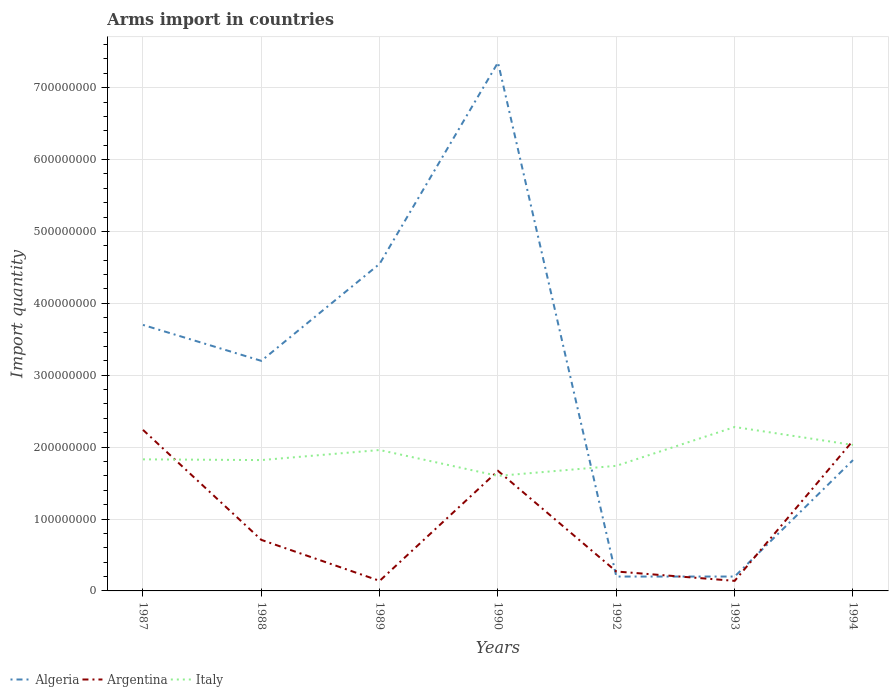How many different coloured lines are there?
Your response must be concise. 3. Does the line corresponding to Argentina intersect with the line corresponding to Italy?
Offer a very short reply. Yes. Across all years, what is the maximum total arms import in Argentina?
Offer a terse response. 1.40e+07. In which year was the total arms import in Algeria maximum?
Give a very brief answer. 1992. What is the total total arms import in Algeria in the graph?
Your answer should be compact. 3.50e+08. What is the difference between the highest and the second highest total arms import in Algeria?
Ensure brevity in your answer.  7.15e+08. What is the difference between the highest and the lowest total arms import in Italy?
Make the answer very short. 3. Is the total arms import in Algeria strictly greater than the total arms import in Italy over the years?
Offer a very short reply. No. How many lines are there?
Your response must be concise. 3. How many years are there in the graph?
Your answer should be very brief. 7. What is the difference between two consecutive major ticks on the Y-axis?
Ensure brevity in your answer.  1.00e+08. Where does the legend appear in the graph?
Make the answer very short. Bottom left. How many legend labels are there?
Offer a terse response. 3. How are the legend labels stacked?
Ensure brevity in your answer.  Horizontal. What is the title of the graph?
Give a very brief answer. Arms import in countries. Does "Panama" appear as one of the legend labels in the graph?
Your answer should be very brief. No. What is the label or title of the X-axis?
Offer a terse response. Years. What is the label or title of the Y-axis?
Your response must be concise. Import quantity. What is the Import quantity of Algeria in 1987?
Provide a succinct answer. 3.70e+08. What is the Import quantity of Argentina in 1987?
Provide a short and direct response. 2.24e+08. What is the Import quantity of Italy in 1987?
Your answer should be compact. 1.83e+08. What is the Import quantity in Algeria in 1988?
Make the answer very short. 3.20e+08. What is the Import quantity in Argentina in 1988?
Your response must be concise. 7.10e+07. What is the Import quantity of Italy in 1988?
Provide a succinct answer. 1.82e+08. What is the Import quantity of Algeria in 1989?
Provide a short and direct response. 4.55e+08. What is the Import quantity of Argentina in 1989?
Keep it short and to the point. 1.40e+07. What is the Import quantity in Italy in 1989?
Provide a succinct answer. 1.96e+08. What is the Import quantity in Algeria in 1990?
Offer a very short reply. 7.35e+08. What is the Import quantity of Argentina in 1990?
Offer a terse response. 1.67e+08. What is the Import quantity in Italy in 1990?
Your answer should be very brief. 1.60e+08. What is the Import quantity of Argentina in 1992?
Offer a very short reply. 2.70e+07. What is the Import quantity in Italy in 1992?
Offer a terse response. 1.74e+08. What is the Import quantity in Argentina in 1993?
Your answer should be very brief. 1.40e+07. What is the Import quantity in Italy in 1993?
Make the answer very short. 2.28e+08. What is the Import quantity in Algeria in 1994?
Offer a terse response. 1.82e+08. What is the Import quantity of Argentina in 1994?
Provide a short and direct response. 2.09e+08. What is the Import quantity of Italy in 1994?
Your answer should be compact. 2.03e+08. Across all years, what is the maximum Import quantity in Algeria?
Ensure brevity in your answer.  7.35e+08. Across all years, what is the maximum Import quantity of Argentina?
Offer a terse response. 2.24e+08. Across all years, what is the maximum Import quantity of Italy?
Your answer should be very brief. 2.28e+08. Across all years, what is the minimum Import quantity of Algeria?
Offer a very short reply. 2.00e+07. Across all years, what is the minimum Import quantity of Argentina?
Provide a succinct answer. 1.40e+07. Across all years, what is the minimum Import quantity in Italy?
Provide a short and direct response. 1.60e+08. What is the total Import quantity in Algeria in the graph?
Keep it short and to the point. 2.10e+09. What is the total Import quantity of Argentina in the graph?
Your answer should be very brief. 7.26e+08. What is the total Import quantity of Italy in the graph?
Ensure brevity in your answer.  1.33e+09. What is the difference between the Import quantity of Argentina in 1987 and that in 1988?
Provide a short and direct response. 1.53e+08. What is the difference between the Import quantity in Italy in 1987 and that in 1988?
Offer a terse response. 1.00e+06. What is the difference between the Import quantity of Algeria in 1987 and that in 1989?
Give a very brief answer. -8.50e+07. What is the difference between the Import quantity in Argentina in 1987 and that in 1989?
Ensure brevity in your answer.  2.10e+08. What is the difference between the Import quantity of Italy in 1987 and that in 1989?
Provide a short and direct response. -1.30e+07. What is the difference between the Import quantity of Algeria in 1987 and that in 1990?
Make the answer very short. -3.65e+08. What is the difference between the Import quantity of Argentina in 1987 and that in 1990?
Make the answer very short. 5.70e+07. What is the difference between the Import quantity of Italy in 1987 and that in 1990?
Give a very brief answer. 2.30e+07. What is the difference between the Import quantity of Algeria in 1987 and that in 1992?
Give a very brief answer. 3.50e+08. What is the difference between the Import quantity of Argentina in 1987 and that in 1992?
Provide a short and direct response. 1.97e+08. What is the difference between the Import quantity in Italy in 1987 and that in 1992?
Keep it short and to the point. 9.00e+06. What is the difference between the Import quantity of Algeria in 1987 and that in 1993?
Your response must be concise. 3.50e+08. What is the difference between the Import quantity in Argentina in 1987 and that in 1993?
Ensure brevity in your answer.  2.10e+08. What is the difference between the Import quantity in Italy in 1987 and that in 1993?
Make the answer very short. -4.50e+07. What is the difference between the Import quantity of Algeria in 1987 and that in 1994?
Your answer should be very brief. 1.88e+08. What is the difference between the Import quantity in Argentina in 1987 and that in 1994?
Keep it short and to the point. 1.50e+07. What is the difference between the Import quantity in Italy in 1987 and that in 1994?
Ensure brevity in your answer.  -2.00e+07. What is the difference between the Import quantity in Algeria in 1988 and that in 1989?
Make the answer very short. -1.35e+08. What is the difference between the Import quantity of Argentina in 1988 and that in 1989?
Ensure brevity in your answer.  5.70e+07. What is the difference between the Import quantity in Italy in 1988 and that in 1989?
Offer a very short reply. -1.40e+07. What is the difference between the Import quantity of Algeria in 1988 and that in 1990?
Your response must be concise. -4.15e+08. What is the difference between the Import quantity of Argentina in 1988 and that in 1990?
Offer a very short reply. -9.60e+07. What is the difference between the Import quantity in Italy in 1988 and that in 1990?
Ensure brevity in your answer.  2.20e+07. What is the difference between the Import quantity of Algeria in 1988 and that in 1992?
Keep it short and to the point. 3.00e+08. What is the difference between the Import quantity in Argentina in 1988 and that in 1992?
Offer a very short reply. 4.40e+07. What is the difference between the Import quantity of Italy in 1988 and that in 1992?
Your answer should be compact. 8.00e+06. What is the difference between the Import quantity of Algeria in 1988 and that in 1993?
Provide a short and direct response. 3.00e+08. What is the difference between the Import quantity of Argentina in 1988 and that in 1993?
Your response must be concise. 5.70e+07. What is the difference between the Import quantity in Italy in 1988 and that in 1993?
Your response must be concise. -4.60e+07. What is the difference between the Import quantity of Algeria in 1988 and that in 1994?
Provide a short and direct response. 1.38e+08. What is the difference between the Import quantity of Argentina in 1988 and that in 1994?
Provide a succinct answer. -1.38e+08. What is the difference between the Import quantity in Italy in 1988 and that in 1994?
Provide a short and direct response. -2.10e+07. What is the difference between the Import quantity of Algeria in 1989 and that in 1990?
Provide a succinct answer. -2.80e+08. What is the difference between the Import quantity in Argentina in 1989 and that in 1990?
Make the answer very short. -1.53e+08. What is the difference between the Import quantity of Italy in 1989 and that in 1990?
Keep it short and to the point. 3.60e+07. What is the difference between the Import quantity of Algeria in 1989 and that in 1992?
Ensure brevity in your answer.  4.35e+08. What is the difference between the Import quantity of Argentina in 1989 and that in 1992?
Ensure brevity in your answer.  -1.30e+07. What is the difference between the Import quantity of Italy in 1989 and that in 1992?
Your response must be concise. 2.20e+07. What is the difference between the Import quantity of Algeria in 1989 and that in 1993?
Ensure brevity in your answer.  4.35e+08. What is the difference between the Import quantity of Italy in 1989 and that in 1993?
Your answer should be compact. -3.20e+07. What is the difference between the Import quantity of Algeria in 1989 and that in 1994?
Provide a succinct answer. 2.73e+08. What is the difference between the Import quantity in Argentina in 1989 and that in 1994?
Ensure brevity in your answer.  -1.95e+08. What is the difference between the Import quantity in Italy in 1989 and that in 1994?
Your answer should be compact. -7.00e+06. What is the difference between the Import quantity in Algeria in 1990 and that in 1992?
Make the answer very short. 7.15e+08. What is the difference between the Import quantity of Argentina in 1990 and that in 1992?
Offer a terse response. 1.40e+08. What is the difference between the Import quantity of Italy in 1990 and that in 1992?
Your answer should be very brief. -1.40e+07. What is the difference between the Import quantity in Algeria in 1990 and that in 1993?
Make the answer very short. 7.15e+08. What is the difference between the Import quantity in Argentina in 1990 and that in 1993?
Your answer should be very brief. 1.53e+08. What is the difference between the Import quantity of Italy in 1990 and that in 1993?
Make the answer very short. -6.80e+07. What is the difference between the Import quantity in Algeria in 1990 and that in 1994?
Offer a terse response. 5.53e+08. What is the difference between the Import quantity of Argentina in 1990 and that in 1994?
Give a very brief answer. -4.20e+07. What is the difference between the Import quantity of Italy in 1990 and that in 1994?
Give a very brief answer. -4.30e+07. What is the difference between the Import quantity in Algeria in 1992 and that in 1993?
Ensure brevity in your answer.  0. What is the difference between the Import quantity in Argentina in 1992 and that in 1993?
Your response must be concise. 1.30e+07. What is the difference between the Import quantity in Italy in 1992 and that in 1993?
Offer a terse response. -5.40e+07. What is the difference between the Import quantity in Algeria in 1992 and that in 1994?
Offer a very short reply. -1.62e+08. What is the difference between the Import quantity in Argentina in 1992 and that in 1994?
Your answer should be very brief. -1.82e+08. What is the difference between the Import quantity in Italy in 1992 and that in 1994?
Your response must be concise. -2.90e+07. What is the difference between the Import quantity of Algeria in 1993 and that in 1994?
Provide a short and direct response. -1.62e+08. What is the difference between the Import quantity in Argentina in 1993 and that in 1994?
Offer a terse response. -1.95e+08. What is the difference between the Import quantity in Italy in 1993 and that in 1994?
Offer a very short reply. 2.50e+07. What is the difference between the Import quantity in Algeria in 1987 and the Import quantity in Argentina in 1988?
Offer a very short reply. 2.99e+08. What is the difference between the Import quantity in Algeria in 1987 and the Import quantity in Italy in 1988?
Your response must be concise. 1.88e+08. What is the difference between the Import quantity in Argentina in 1987 and the Import quantity in Italy in 1988?
Your answer should be compact. 4.20e+07. What is the difference between the Import quantity of Algeria in 1987 and the Import quantity of Argentina in 1989?
Offer a terse response. 3.56e+08. What is the difference between the Import quantity in Algeria in 1987 and the Import quantity in Italy in 1989?
Your answer should be very brief. 1.74e+08. What is the difference between the Import quantity in Argentina in 1987 and the Import quantity in Italy in 1989?
Ensure brevity in your answer.  2.80e+07. What is the difference between the Import quantity in Algeria in 1987 and the Import quantity in Argentina in 1990?
Offer a very short reply. 2.03e+08. What is the difference between the Import quantity in Algeria in 1987 and the Import quantity in Italy in 1990?
Keep it short and to the point. 2.10e+08. What is the difference between the Import quantity of Argentina in 1987 and the Import quantity of Italy in 1990?
Make the answer very short. 6.40e+07. What is the difference between the Import quantity in Algeria in 1987 and the Import quantity in Argentina in 1992?
Keep it short and to the point. 3.43e+08. What is the difference between the Import quantity of Algeria in 1987 and the Import quantity of Italy in 1992?
Offer a terse response. 1.96e+08. What is the difference between the Import quantity in Argentina in 1987 and the Import quantity in Italy in 1992?
Ensure brevity in your answer.  5.00e+07. What is the difference between the Import quantity of Algeria in 1987 and the Import quantity of Argentina in 1993?
Offer a terse response. 3.56e+08. What is the difference between the Import quantity in Algeria in 1987 and the Import quantity in Italy in 1993?
Make the answer very short. 1.42e+08. What is the difference between the Import quantity in Argentina in 1987 and the Import quantity in Italy in 1993?
Provide a short and direct response. -4.00e+06. What is the difference between the Import quantity of Algeria in 1987 and the Import quantity of Argentina in 1994?
Give a very brief answer. 1.61e+08. What is the difference between the Import quantity in Algeria in 1987 and the Import quantity in Italy in 1994?
Offer a very short reply. 1.67e+08. What is the difference between the Import quantity of Argentina in 1987 and the Import quantity of Italy in 1994?
Keep it short and to the point. 2.10e+07. What is the difference between the Import quantity of Algeria in 1988 and the Import quantity of Argentina in 1989?
Provide a short and direct response. 3.06e+08. What is the difference between the Import quantity of Algeria in 1988 and the Import quantity of Italy in 1989?
Keep it short and to the point. 1.24e+08. What is the difference between the Import quantity in Argentina in 1988 and the Import quantity in Italy in 1989?
Offer a very short reply. -1.25e+08. What is the difference between the Import quantity in Algeria in 1988 and the Import quantity in Argentina in 1990?
Your answer should be compact. 1.53e+08. What is the difference between the Import quantity of Algeria in 1988 and the Import quantity of Italy in 1990?
Your response must be concise. 1.60e+08. What is the difference between the Import quantity of Argentina in 1988 and the Import quantity of Italy in 1990?
Ensure brevity in your answer.  -8.90e+07. What is the difference between the Import quantity in Algeria in 1988 and the Import quantity in Argentina in 1992?
Your answer should be compact. 2.93e+08. What is the difference between the Import quantity in Algeria in 1988 and the Import quantity in Italy in 1992?
Keep it short and to the point. 1.46e+08. What is the difference between the Import quantity of Argentina in 1988 and the Import quantity of Italy in 1992?
Your response must be concise. -1.03e+08. What is the difference between the Import quantity of Algeria in 1988 and the Import quantity of Argentina in 1993?
Keep it short and to the point. 3.06e+08. What is the difference between the Import quantity in Algeria in 1988 and the Import quantity in Italy in 1993?
Your response must be concise. 9.20e+07. What is the difference between the Import quantity in Argentina in 1988 and the Import quantity in Italy in 1993?
Your answer should be compact. -1.57e+08. What is the difference between the Import quantity in Algeria in 1988 and the Import quantity in Argentina in 1994?
Keep it short and to the point. 1.11e+08. What is the difference between the Import quantity of Algeria in 1988 and the Import quantity of Italy in 1994?
Your answer should be compact. 1.17e+08. What is the difference between the Import quantity in Argentina in 1988 and the Import quantity in Italy in 1994?
Give a very brief answer. -1.32e+08. What is the difference between the Import quantity of Algeria in 1989 and the Import quantity of Argentina in 1990?
Provide a succinct answer. 2.88e+08. What is the difference between the Import quantity in Algeria in 1989 and the Import quantity in Italy in 1990?
Make the answer very short. 2.95e+08. What is the difference between the Import quantity of Argentina in 1989 and the Import quantity of Italy in 1990?
Provide a short and direct response. -1.46e+08. What is the difference between the Import quantity in Algeria in 1989 and the Import quantity in Argentina in 1992?
Ensure brevity in your answer.  4.28e+08. What is the difference between the Import quantity in Algeria in 1989 and the Import quantity in Italy in 1992?
Offer a very short reply. 2.81e+08. What is the difference between the Import quantity in Argentina in 1989 and the Import quantity in Italy in 1992?
Offer a very short reply. -1.60e+08. What is the difference between the Import quantity in Algeria in 1989 and the Import quantity in Argentina in 1993?
Provide a succinct answer. 4.41e+08. What is the difference between the Import quantity in Algeria in 1989 and the Import quantity in Italy in 1993?
Give a very brief answer. 2.27e+08. What is the difference between the Import quantity in Argentina in 1989 and the Import quantity in Italy in 1993?
Give a very brief answer. -2.14e+08. What is the difference between the Import quantity in Algeria in 1989 and the Import quantity in Argentina in 1994?
Provide a short and direct response. 2.46e+08. What is the difference between the Import quantity of Algeria in 1989 and the Import quantity of Italy in 1994?
Make the answer very short. 2.52e+08. What is the difference between the Import quantity in Argentina in 1989 and the Import quantity in Italy in 1994?
Provide a succinct answer. -1.89e+08. What is the difference between the Import quantity of Algeria in 1990 and the Import quantity of Argentina in 1992?
Your answer should be compact. 7.08e+08. What is the difference between the Import quantity in Algeria in 1990 and the Import quantity in Italy in 1992?
Offer a very short reply. 5.61e+08. What is the difference between the Import quantity in Argentina in 1990 and the Import quantity in Italy in 1992?
Your answer should be compact. -7.00e+06. What is the difference between the Import quantity of Algeria in 1990 and the Import quantity of Argentina in 1993?
Give a very brief answer. 7.21e+08. What is the difference between the Import quantity of Algeria in 1990 and the Import quantity of Italy in 1993?
Provide a short and direct response. 5.07e+08. What is the difference between the Import quantity of Argentina in 1990 and the Import quantity of Italy in 1993?
Your answer should be compact. -6.10e+07. What is the difference between the Import quantity of Algeria in 1990 and the Import quantity of Argentina in 1994?
Provide a short and direct response. 5.26e+08. What is the difference between the Import quantity in Algeria in 1990 and the Import quantity in Italy in 1994?
Provide a short and direct response. 5.32e+08. What is the difference between the Import quantity of Argentina in 1990 and the Import quantity of Italy in 1994?
Make the answer very short. -3.60e+07. What is the difference between the Import quantity of Algeria in 1992 and the Import quantity of Argentina in 1993?
Give a very brief answer. 6.00e+06. What is the difference between the Import quantity of Algeria in 1992 and the Import quantity of Italy in 1993?
Ensure brevity in your answer.  -2.08e+08. What is the difference between the Import quantity of Argentina in 1992 and the Import quantity of Italy in 1993?
Your answer should be compact. -2.01e+08. What is the difference between the Import quantity in Algeria in 1992 and the Import quantity in Argentina in 1994?
Give a very brief answer. -1.89e+08. What is the difference between the Import quantity of Algeria in 1992 and the Import quantity of Italy in 1994?
Offer a terse response. -1.83e+08. What is the difference between the Import quantity of Argentina in 1992 and the Import quantity of Italy in 1994?
Give a very brief answer. -1.76e+08. What is the difference between the Import quantity of Algeria in 1993 and the Import quantity of Argentina in 1994?
Your answer should be compact. -1.89e+08. What is the difference between the Import quantity in Algeria in 1993 and the Import quantity in Italy in 1994?
Your answer should be compact. -1.83e+08. What is the difference between the Import quantity in Argentina in 1993 and the Import quantity in Italy in 1994?
Your answer should be very brief. -1.89e+08. What is the average Import quantity of Algeria per year?
Provide a succinct answer. 3.00e+08. What is the average Import quantity in Argentina per year?
Provide a short and direct response. 1.04e+08. What is the average Import quantity in Italy per year?
Make the answer very short. 1.89e+08. In the year 1987, what is the difference between the Import quantity in Algeria and Import quantity in Argentina?
Keep it short and to the point. 1.46e+08. In the year 1987, what is the difference between the Import quantity in Algeria and Import quantity in Italy?
Your answer should be compact. 1.87e+08. In the year 1987, what is the difference between the Import quantity of Argentina and Import quantity of Italy?
Your answer should be very brief. 4.10e+07. In the year 1988, what is the difference between the Import quantity in Algeria and Import quantity in Argentina?
Provide a succinct answer. 2.49e+08. In the year 1988, what is the difference between the Import quantity of Algeria and Import quantity of Italy?
Your response must be concise. 1.38e+08. In the year 1988, what is the difference between the Import quantity of Argentina and Import quantity of Italy?
Your response must be concise. -1.11e+08. In the year 1989, what is the difference between the Import quantity in Algeria and Import quantity in Argentina?
Ensure brevity in your answer.  4.41e+08. In the year 1989, what is the difference between the Import quantity of Algeria and Import quantity of Italy?
Your answer should be compact. 2.59e+08. In the year 1989, what is the difference between the Import quantity of Argentina and Import quantity of Italy?
Provide a succinct answer. -1.82e+08. In the year 1990, what is the difference between the Import quantity in Algeria and Import quantity in Argentina?
Give a very brief answer. 5.68e+08. In the year 1990, what is the difference between the Import quantity of Algeria and Import quantity of Italy?
Ensure brevity in your answer.  5.75e+08. In the year 1992, what is the difference between the Import quantity in Algeria and Import quantity in Argentina?
Keep it short and to the point. -7.00e+06. In the year 1992, what is the difference between the Import quantity in Algeria and Import quantity in Italy?
Give a very brief answer. -1.54e+08. In the year 1992, what is the difference between the Import quantity of Argentina and Import quantity of Italy?
Give a very brief answer. -1.47e+08. In the year 1993, what is the difference between the Import quantity of Algeria and Import quantity of Italy?
Provide a short and direct response. -2.08e+08. In the year 1993, what is the difference between the Import quantity in Argentina and Import quantity in Italy?
Ensure brevity in your answer.  -2.14e+08. In the year 1994, what is the difference between the Import quantity of Algeria and Import quantity of Argentina?
Keep it short and to the point. -2.70e+07. In the year 1994, what is the difference between the Import quantity of Algeria and Import quantity of Italy?
Provide a succinct answer. -2.10e+07. What is the ratio of the Import quantity in Algeria in 1987 to that in 1988?
Your answer should be compact. 1.16. What is the ratio of the Import quantity of Argentina in 1987 to that in 1988?
Your response must be concise. 3.15. What is the ratio of the Import quantity in Algeria in 1987 to that in 1989?
Offer a terse response. 0.81. What is the ratio of the Import quantity of Argentina in 1987 to that in 1989?
Give a very brief answer. 16. What is the ratio of the Import quantity in Italy in 1987 to that in 1989?
Give a very brief answer. 0.93. What is the ratio of the Import quantity of Algeria in 1987 to that in 1990?
Offer a terse response. 0.5. What is the ratio of the Import quantity of Argentina in 1987 to that in 1990?
Offer a very short reply. 1.34. What is the ratio of the Import quantity of Italy in 1987 to that in 1990?
Give a very brief answer. 1.14. What is the ratio of the Import quantity of Algeria in 1987 to that in 1992?
Keep it short and to the point. 18.5. What is the ratio of the Import quantity in Argentina in 1987 to that in 1992?
Offer a very short reply. 8.3. What is the ratio of the Import quantity in Italy in 1987 to that in 1992?
Give a very brief answer. 1.05. What is the ratio of the Import quantity in Algeria in 1987 to that in 1993?
Your answer should be very brief. 18.5. What is the ratio of the Import quantity of Italy in 1987 to that in 1993?
Ensure brevity in your answer.  0.8. What is the ratio of the Import quantity in Algeria in 1987 to that in 1994?
Your answer should be compact. 2.03. What is the ratio of the Import quantity in Argentina in 1987 to that in 1994?
Provide a succinct answer. 1.07. What is the ratio of the Import quantity of Italy in 1987 to that in 1994?
Make the answer very short. 0.9. What is the ratio of the Import quantity of Algeria in 1988 to that in 1989?
Provide a succinct answer. 0.7. What is the ratio of the Import quantity of Argentina in 1988 to that in 1989?
Your answer should be compact. 5.07. What is the ratio of the Import quantity in Algeria in 1988 to that in 1990?
Your answer should be very brief. 0.44. What is the ratio of the Import quantity in Argentina in 1988 to that in 1990?
Your answer should be very brief. 0.43. What is the ratio of the Import quantity in Italy in 1988 to that in 1990?
Give a very brief answer. 1.14. What is the ratio of the Import quantity in Argentina in 1988 to that in 1992?
Offer a terse response. 2.63. What is the ratio of the Import quantity of Italy in 1988 to that in 1992?
Provide a short and direct response. 1.05. What is the ratio of the Import quantity of Algeria in 1988 to that in 1993?
Your answer should be compact. 16. What is the ratio of the Import quantity in Argentina in 1988 to that in 1993?
Your response must be concise. 5.07. What is the ratio of the Import quantity of Italy in 1988 to that in 1993?
Give a very brief answer. 0.8. What is the ratio of the Import quantity of Algeria in 1988 to that in 1994?
Provide a short and direct response. 1.76. What is the ratio of the Import quantity in Argentina in 1988 to that in 1994?
Your answer should be very brief. 0.34. What is the ratio of the Import quantity of Italy in 1988 to that in 1994?
Give a very brief answer. 0.9. What is the ratio of the Import quantity in Algeria in 1989 to that in 1990?
Provide a short and direct response. 0.62. What is the ratio of the Import quantity in Argentina in 1989 to that in 1990?
Provide a succinct answer. 0.08. What is the ratio of the Import quantity in Italy in 1989 to that in 1990?
Your answer should be compact. 1.23. What is the ratio of the Import quantity of Algeria in 1989 to that in 1992?
Keep it short and to the point. 22.75. What is the ratio of the Import quantity in Argentina in 1989 to that in 1992?
Ensure brevity in your answer.  0.52. What is the ratio of the Import quantity of Italy in 1989 to that in 1992?
Make the answer very short. 1.13. What is the ratio of the Import quantity in Algeria in 1989 to that in 1993?
Keep it short and to the point. 22.75. What is the ratio of the Import quantity in Argentina in 1989 to that in 1993?
Give a very brief answer. 1. What is the ratio of the Import quantity in Italy in 1989 to that in 1993?
Offer a very short reply. 0.86. What is the ratio of the Import quantity in Argentina in 1989 to that in 1994?
Offer a very short reply. 0.07. What is the ratio of the Import quantity of Italy in 1989 to that in 1994?
Make the answer very short. 0.97. What is the ratio of the Import quantity in Algeria in 1990 to that in 1992?
Offer a terse response. 36.75. What is the ratio of the Import quantity in Argentina in 1990 to that in 1992?
Ensure brevity in your answer.  6.19. What is the ratio of the Import quantity in Italy in 1990 to that in 1992?
Keep it short and to the point. 0.92. What is the ratio of the Import quantity in Algeria in 1990 to that in 1993?
Give a very brief answer. 36.75. What is the ratio of the Import quantity of Argentina in 1990 to that in 1993?
Your answer should be very brief. 11.93. What is the ratio of the Import quantity of Italy in 1990 to that in 1993?
Your answer should be very brief. 0.7. What is the ratio of the Import quantity in Algeria in 1990 to that in 1994?
Offer a very short reply. 4.04. What is the ratio of the Import quantity of Argentina in 1990 to that in 1994?
Provide a short and direct response. 0.8. What is the ratio of the Import quantity of Italy in 1990 to that in 1994?
Make the answer very short. 0.79. What is the ratio of the Import quantity of Argentina in 1992 to that in 1993?
Your answer should be compact. 1.93. What is the ratio of the Import quantity of Italy in 1992 to that in 1993?
Keep it short and to the point. 0.76. What is the ratio of the Import quantity in Algeria in 1992 to that in 1994?
Your response must be concise. 0.11. What is the ratio of the Import quantity in Argentina in 1992 to that in 1994?
Your answer should be very brief. 0.13. What is the ratio of the Import quantity in Italy in 1992 to that in 1994?
Your answer should be very brief. 0.86. What is the ratio of the Import quantity of Algeria in 1993 to that in 1994?
Your response must be concise. 0.11. What is the ratio of the Import quantity in Argentina in 1993 to that in 1994?
Provide a succinct answer. 0.07. What is the ratio of the Import quantity in Italy in 1993 to that in 1994?
Provide a succinct answer. 1.12. What is the difference between the highest and the second highest Import quantity in Algeria?
Offer a very short reply. 2.80e+08. What is the difference between the highest and the second highest Import quantity in Argentina?
Give a very brief answer. 1.50e+07. What is the difference between the highest and the second highest Import quantity in Italy?
Ensure brevity in your answer.  2.50e+07. What is the difference between the highest and the lowest Import quantity in Algeria?
Offer a terse response. 7.15e+08. What is the difference between the highest and the lowest Import quantity of Argentina?
Your answer should be very brief. 2.10e+08. What is the difference between the highest and the lowest Import quantity of Italy?
Keep it short and to the point. 6.80e+07. 